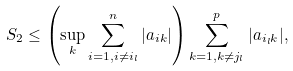<formula> <loc_0><loc_0><loc_500><loc_500>S _ { 2 } \leq \left ( \sup _ { k } \sum _ { i = 1 , i \neq i _ { l } } ^ { n } | a _ { i k } | \right ) \sum _ { k = 1 , k \neq j _ { l } } ^ { p } | a _ { i _ { l } k } | ,</formula> 